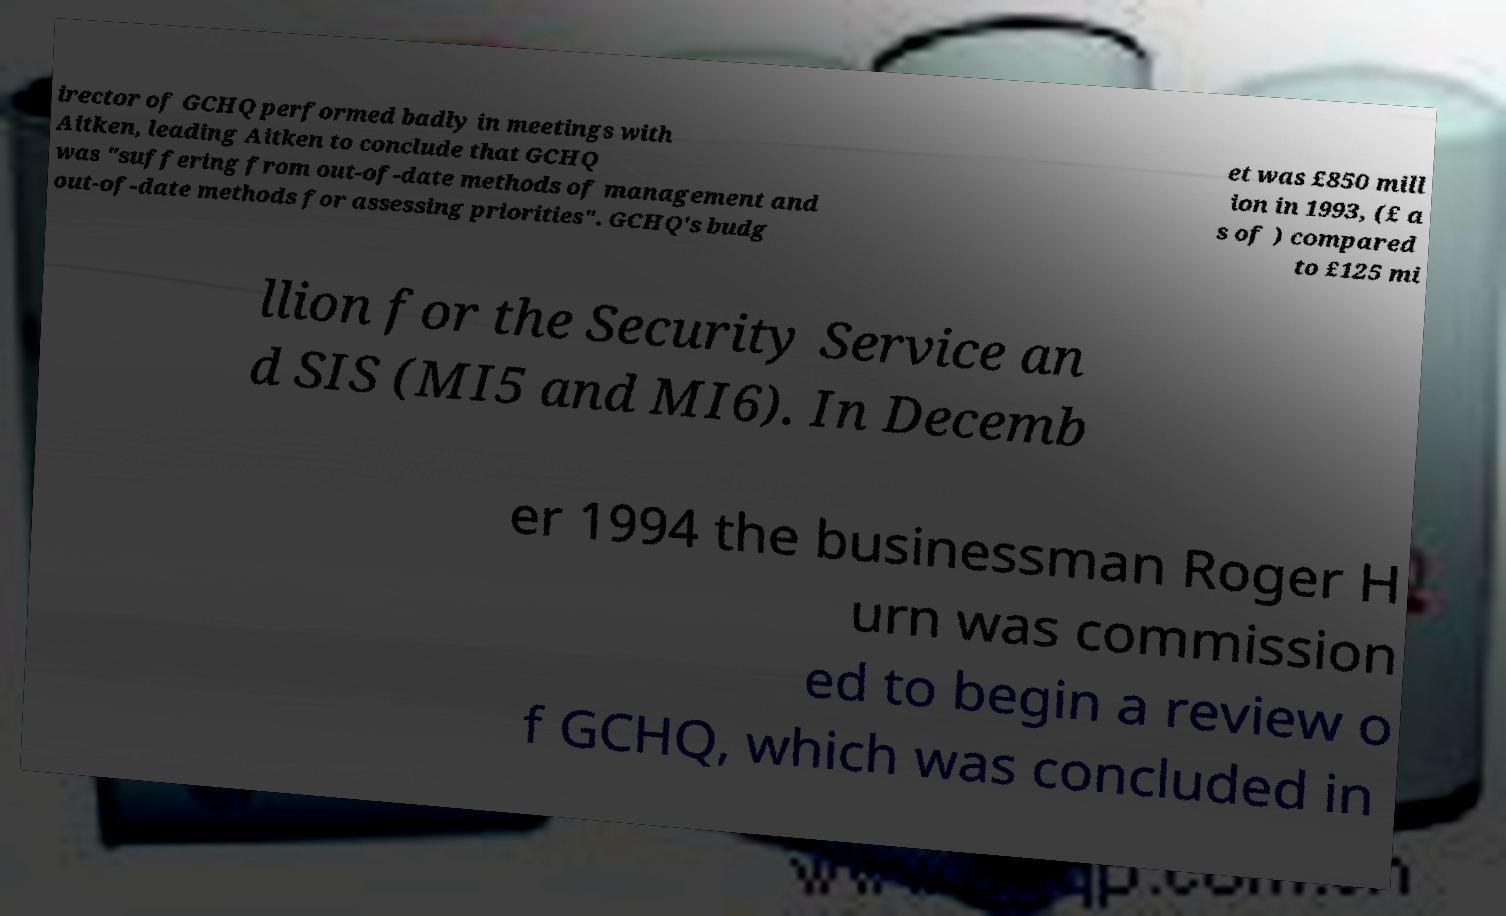For documentation purposes, I need the text within this image transcribed. Could you provide that? irector of GCHQ performed badly in meetings with Aitken, leading Aitken to conclude that GCHQ was "suffering from out-of-date methods of management and out-of-date methods for assessing priorities". GCHQ's budg et was £850 mill ion in 1993, (£ a s of ) compared to £125 mi llion for the Security Service an d SIS (MI5 and MI6). In Decemb er 1994 the businessman Roger H urn was commission ed to begin a review o f GCHQ, which was concluded in 